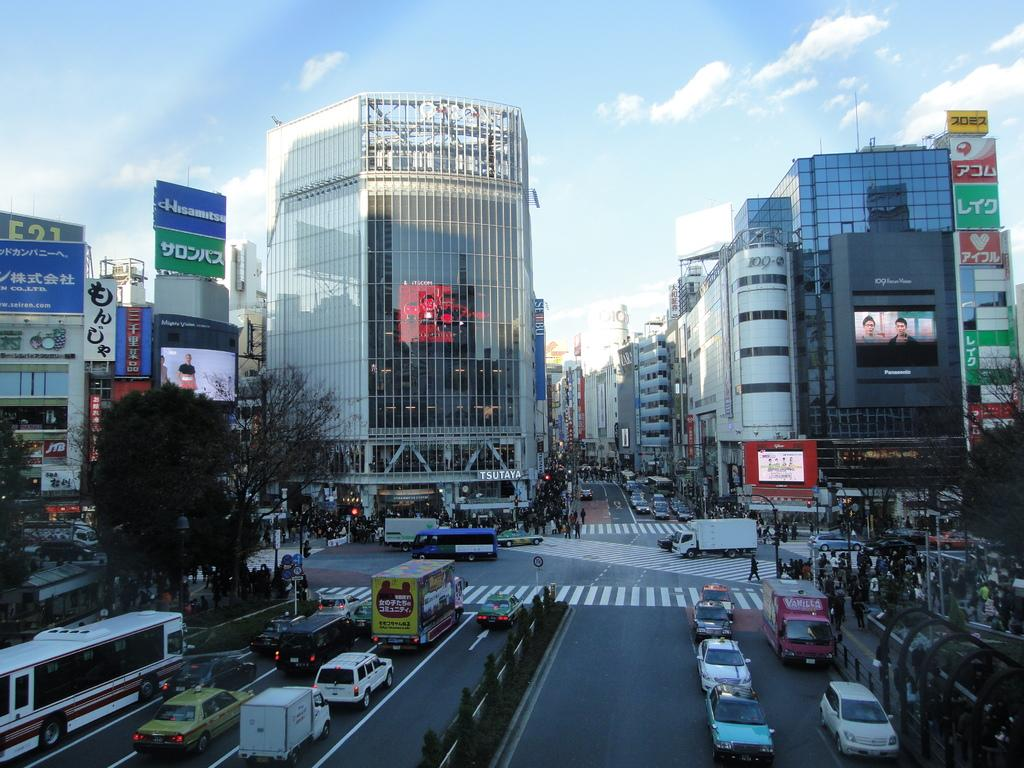How many people are in the image? There is a group of people in the image, but the exact number cannot be determined from the provided facts. What can be seen on the road in the image? There are vehicles on the road in the image. What type of vegetation is visible in the background of the image? There are trees in the background of the image. What type of signs are present in the background of the image? Sign boards, hoardings, and traffic lights are present in the background of the image. What type of structures are visible in the background of the image? Buildings are visible in the background of the image. What type of winter clothing is worn by the people in the image? There is no mention of winter or clothing in the provided facts, so it cannot be determined what type of clothing the people are wearing. How does the guide help the group of people in the image? There is no guide mentioned in the provided facts, so it cannot be determined how a guide might help the group of people. 